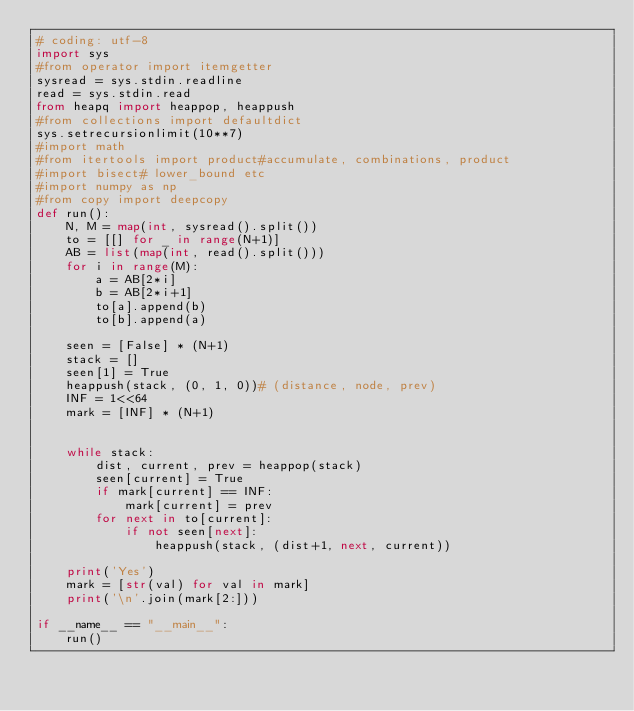Convert code to text. <code><loc_0><loc_0><loc_500><loc_500><_Python_># coding: utf-8
import sys
#from operator import itemgetter
sysread = sys.stdin.readline
read = sys.stdin.read
from heapq import heappop, heappush
#from collections import defaultdict
sys.setrecursionlimit(10**7)
#import math
#from itertools import product#accumulate, combinations, product
#import bisect# lower_bound etc
#import numpy as np
#from copy import deepcopy
def run():
    N, M = map(int, sysread().split())
    to = [[] for _ in range(N+1)]
    AB = list(map(int, read().split()))
    for i in range(M):
        a = AB[2*i]
        b = AB[2*i+1]
        to[a].append(b)
        to[b].append(a)

    seen = [False] * (N+1)
    stack = []
    seen[1] = True
    heappush(stack, (0, 1, 0))# (distance, node, prev)
    INF = 1<<64
    mark = [INF] * (N+1)


    while stack:
        dist, current, prev = heappop(stack)
        seen[current] = True
        if mark[current] == INF:
            mark[current] = prev
        for next in to[current]:
            if not seen[next]:
                heappush(stack, (dist+1, next, current))

    print('Yes')
    mark = [str(val) for val in mark]
    print('\n'.join(mark[2:]))

if __name__ == "__main__":
    run()</code> 